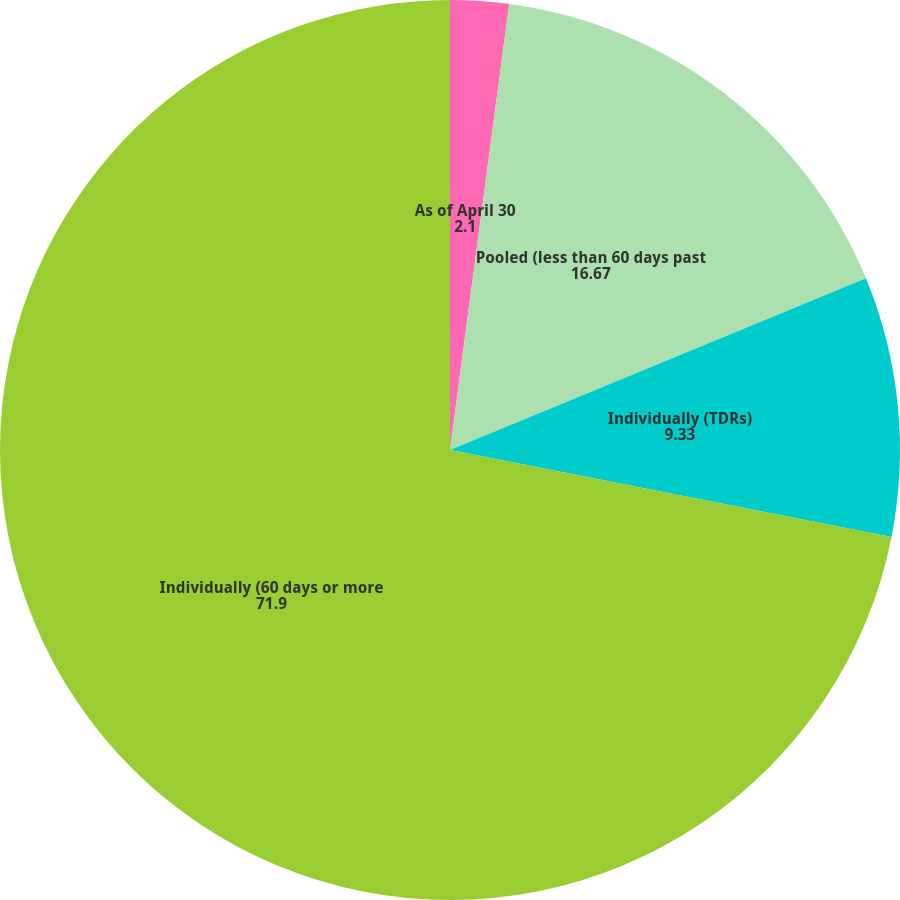Convert chart. <chart><loc_0><loc_0><loc_500><loc_500><pie_chart><fcel>As of April 30<fcel>Pooled (less than 60 days past<fcel>Individually (TDRs)<fcel>Individually (60 days or more<nl><fcel>2.1%<fcel>16.67%<fcel>9.33%<fcel>71.9%<nl></chart> 